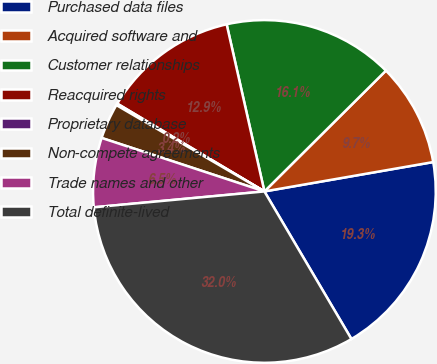Convert chart to OTSL. <chart><loc_0><loc_0><loc_500><loc_500><pie_chart><fcel>Purchased data files<fcel>Acquired software and<fcel>Customer relationships<fcel>Reacquired rights<fcel>Proprietary database<fcel>Non-compete agreements<fcel>Trade names and other<fcel>Total definite-lived<nl><fcel>19.26%<fcel>9.71%<fcel>16.08%<fcel>12.9%<fcel>0.16%<fcel>3.35%<fcel>6.53%<fcel>32.0%<nl></chart> 